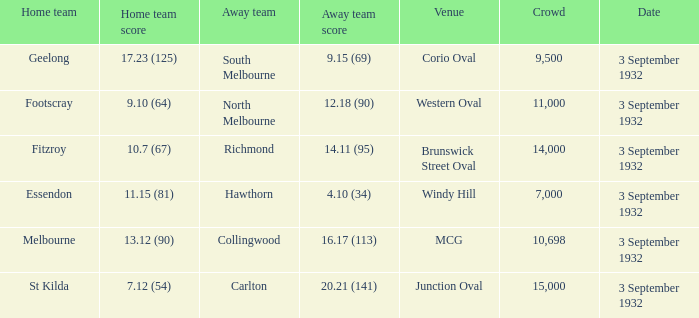18 (90)? 11000.0. 